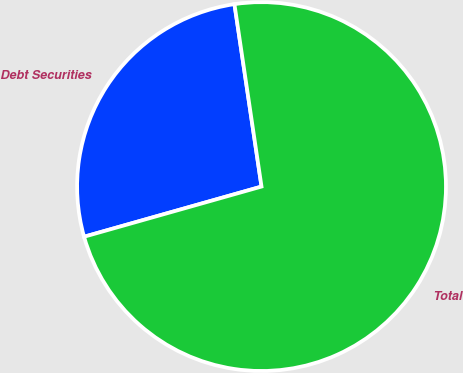<chart> <loc_0><loc_0><loc_500><loc_500><pie_chart><fcel>Debt Securities<fcel>Total<nl><fcel>27.04%<fcel>72.96%<nl></chart> 